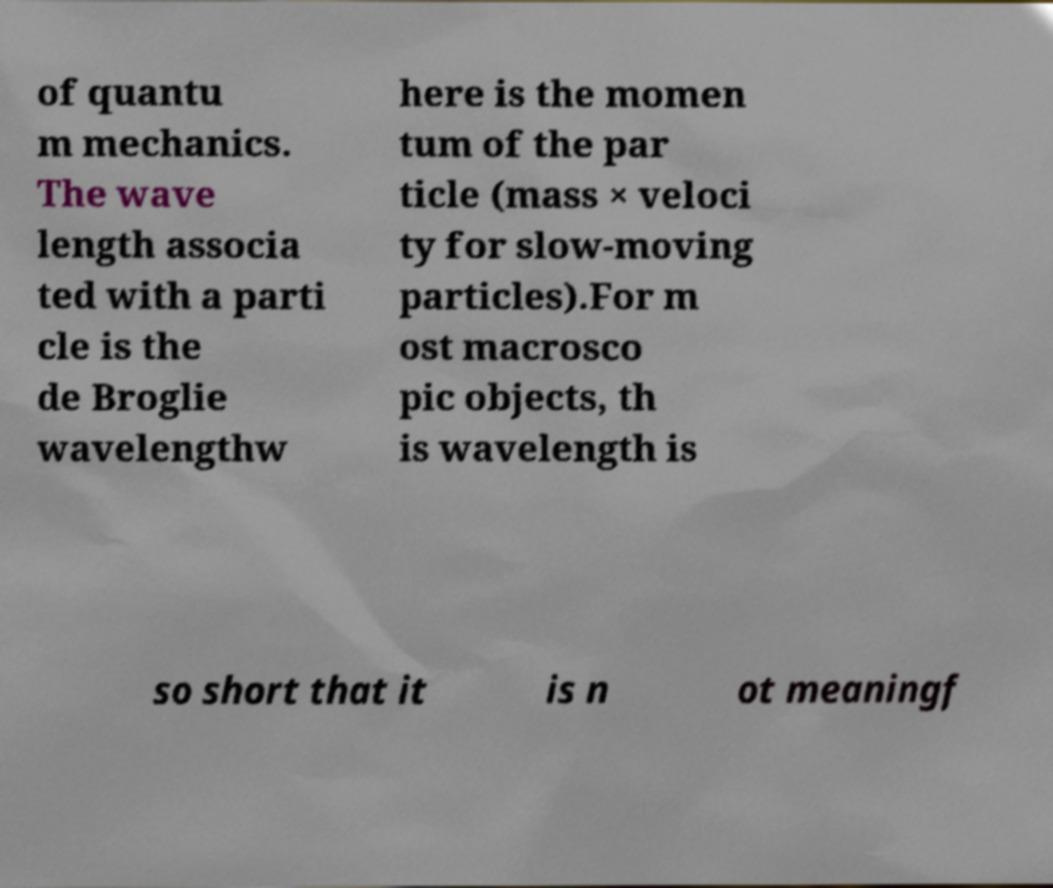What messages or text are displayed in this image? I need them in a readable, typed format. of quantu m mechanics. The wave length associa ted with a parti cle is the de Broglie wavelengthw here is the momen tum of the par ticle (mass × veloci ty for slow-moving particles).For m ost macrosco pic objects, th is wavelength is so short that it is n ot meaningf 